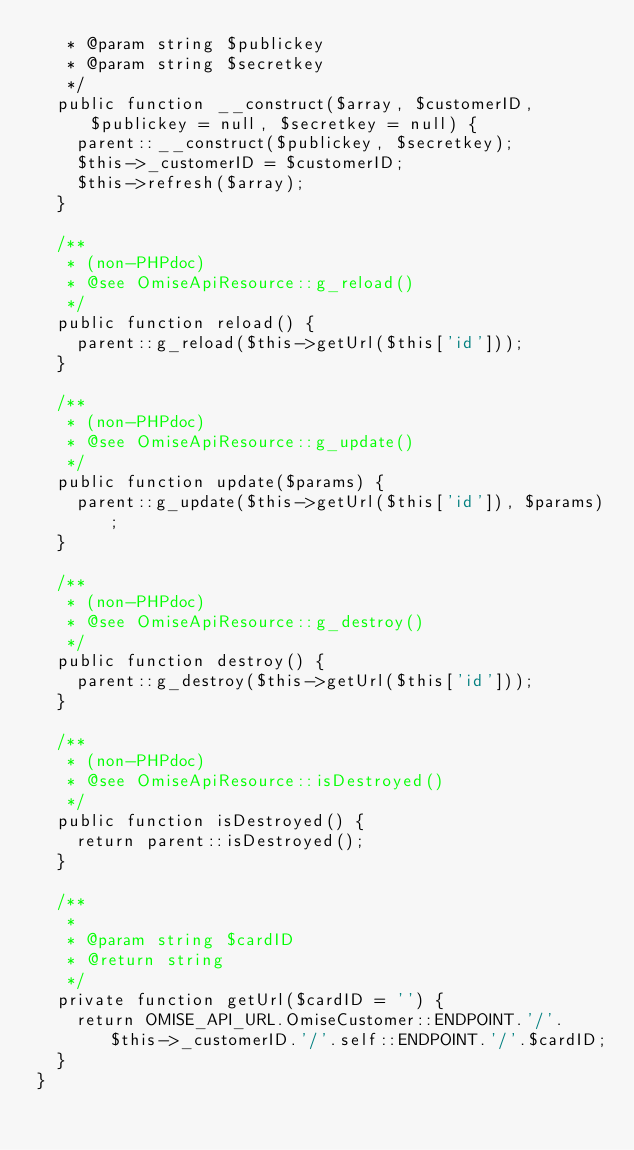Convert code to text. <code><loc_0><loc_0><loc_500><loc_500><_PHP_>   * @param string $publickey
   * @param string $secretkey
   */
  public function __construct($array, $customerID, $publickey = null, $secretkey = null) {
    parent::__construct($publickey, $secretkey);
    $this->_customerID = $customerID;
    $this->refresh($array);
  }

  /**
   * (non-PHPdoc)
   * @see OmiseApiResource::g_reload()
   */
  public function reload() {
    parent::g_reload($this->getUrl($this['id']));
  }

  /**
   * (non-PHPdoc)
   * @see OmiseApiResource::g_update()
   */
  public function update($params) {
    parent::g_update($this->getUrl($this['id']), $params);
  }

  /**
   * (non-PHPdoc)
   * @see OmiseApiResource::g_destroy()
   */
  public function destroy() {
    parent::g_destroy($this->getUrl($this['id']));
  }

  /**
   * (non-PHPdoc)
   * @see OmiseApiResource::isDestroyed()
   */
  public function isDestroyed() {
    return parent::isDestroyed();
  }

  /**
   *
   * @param string $cardID
   * @return string
   */
  private function getUrl($cardID = '') {
    return OMISE_API_URL.OmiseCustomer::ENDPOINT.'/'.$this->_customerID.'/'.self::ENDPOINT.'/'.$cardID;
  }
}
</code> 